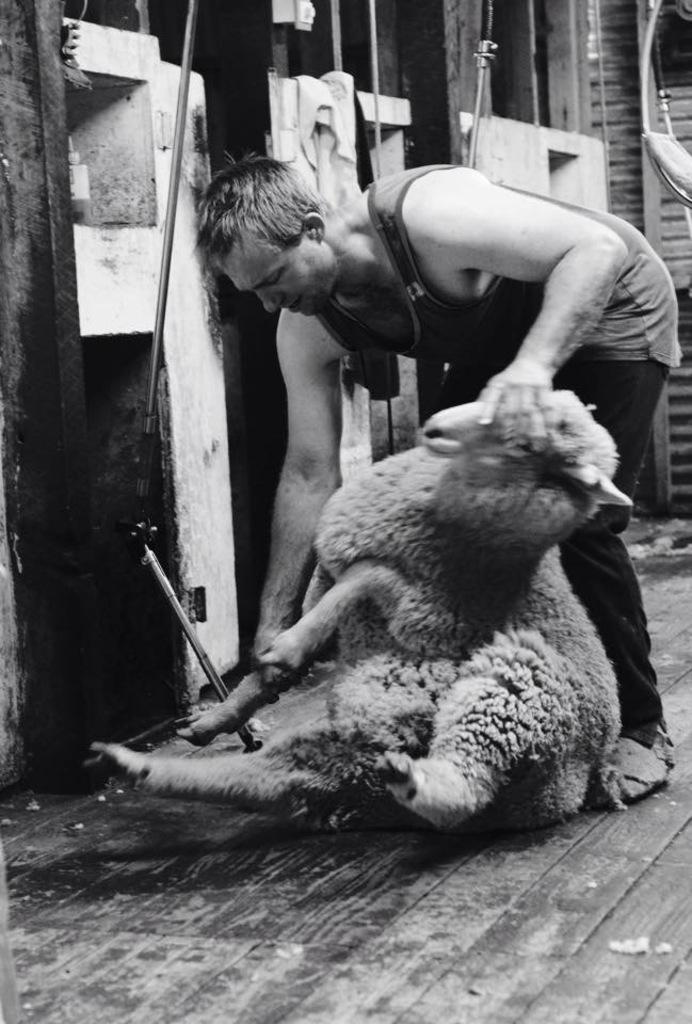Can you describe this image briefly? This is a black and white image where we can see a person holding a sheep and in the background there are metal rods, walls and a few other objects. 